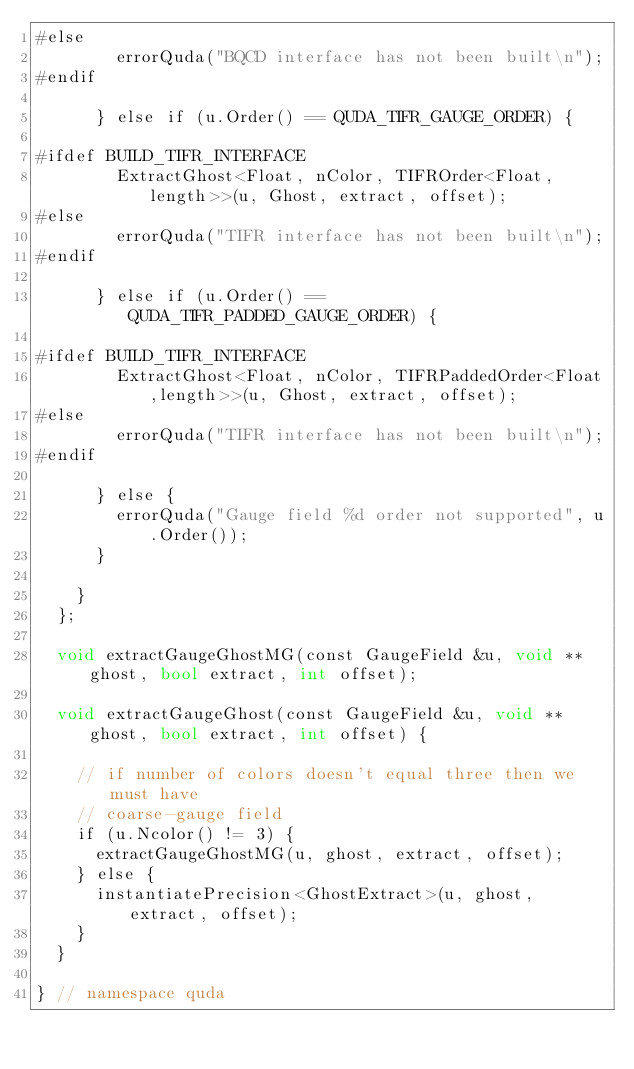Convert code to text. <code><loc_0><loc_0><loc_500><loc_500><_Cuda_>#else
        errorQuda("BQCD interface has not been built\n");
#endif

      } else if (u.Order() == QUDA_TIFR_GAUGE_ORDER) {

#ifdef BUILD_TIFR_INTERFACE
        ExtractGhost<Float, nColor, TIFROrder<Float,length>>(u, Ghost, extract, offset);
#else
        errorQuda("TIFR interface has not been built\n");
#endif

      } else if (u.Order() == QUDA_TIFR_PADDED_GAUGE_ORDER) {

#ifdef BUILD_TIFR_INTERFACE
        ExtractGhost<Float, nColor, TIFRPaddedOrder<Float,length>>(u, Ghost, extract, offset);
#else
        errorQuda("TIFR interface has not been built\n");
#endif

      } else {
        errorQuda("Gauge field %d order not supported", u.Order());
      }

    }
  };

  void extractGaugeGhostMG(const GaugeField &u, void **ghost, bool extract, int offset);

  void extractGaugeGhost(const GaugeField &u, void **ghost, bool extract, int offset) {

    // if number of colors doesn't equal three then we must have
    // coarse-gauge field
    if (u.Ncolor() != 3) {
      extractGaugeGhostMG(u, ghost, extract, offset);
    } else {
      instantiatePrecision<GhostExtract>(u, ghost, extract, offset);
    }
  }

} // namespace quda
</code> 